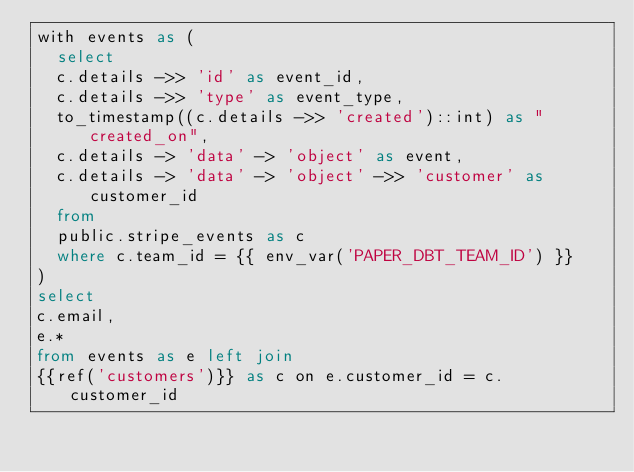<code> <loc_0><loc_0><loc_500><loc_500><_SQL_>with events as (
	select 
	c.details ->> 'id' as event_id,
	c.details ->> 'type' as event_type,
	to_timestamp((c.details ->> 'created')::int) as "created_on",
	c.details -> 'data' -> 'object' as event,
	c.details -> 'data' -> 'object' ->> 'customer' as customer_id
	from 
	public.stripe_events as c 
	where c.team_id = {{ env_var('PAPER_DBT_TEAM_ID') }}
)
select 
c.email,
e.* 
from events as e left join 
{{ref('customers')}} as c on e.customer_id = c.customer_id</code> 